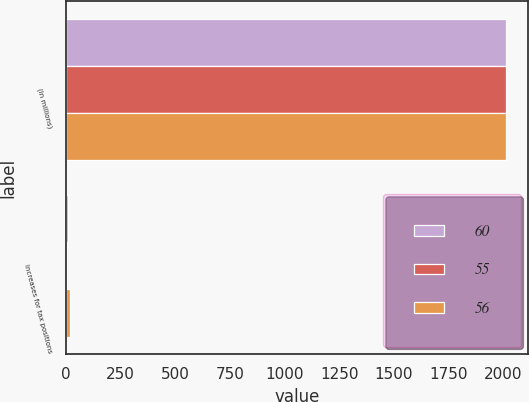Convert chart. <chart><loc_0><loc_0><loc_500><loc_500><stacked_bar_chart><ecel><fcel>(In millions)<fcel>Increases for tax positions<nl><fcel>60<fcel>2014<fcel>10<nl><fcel>55<fcel>2013<fcel>6<nl><fcel>56<fcel>2012<fcel>19<nl></chart> 